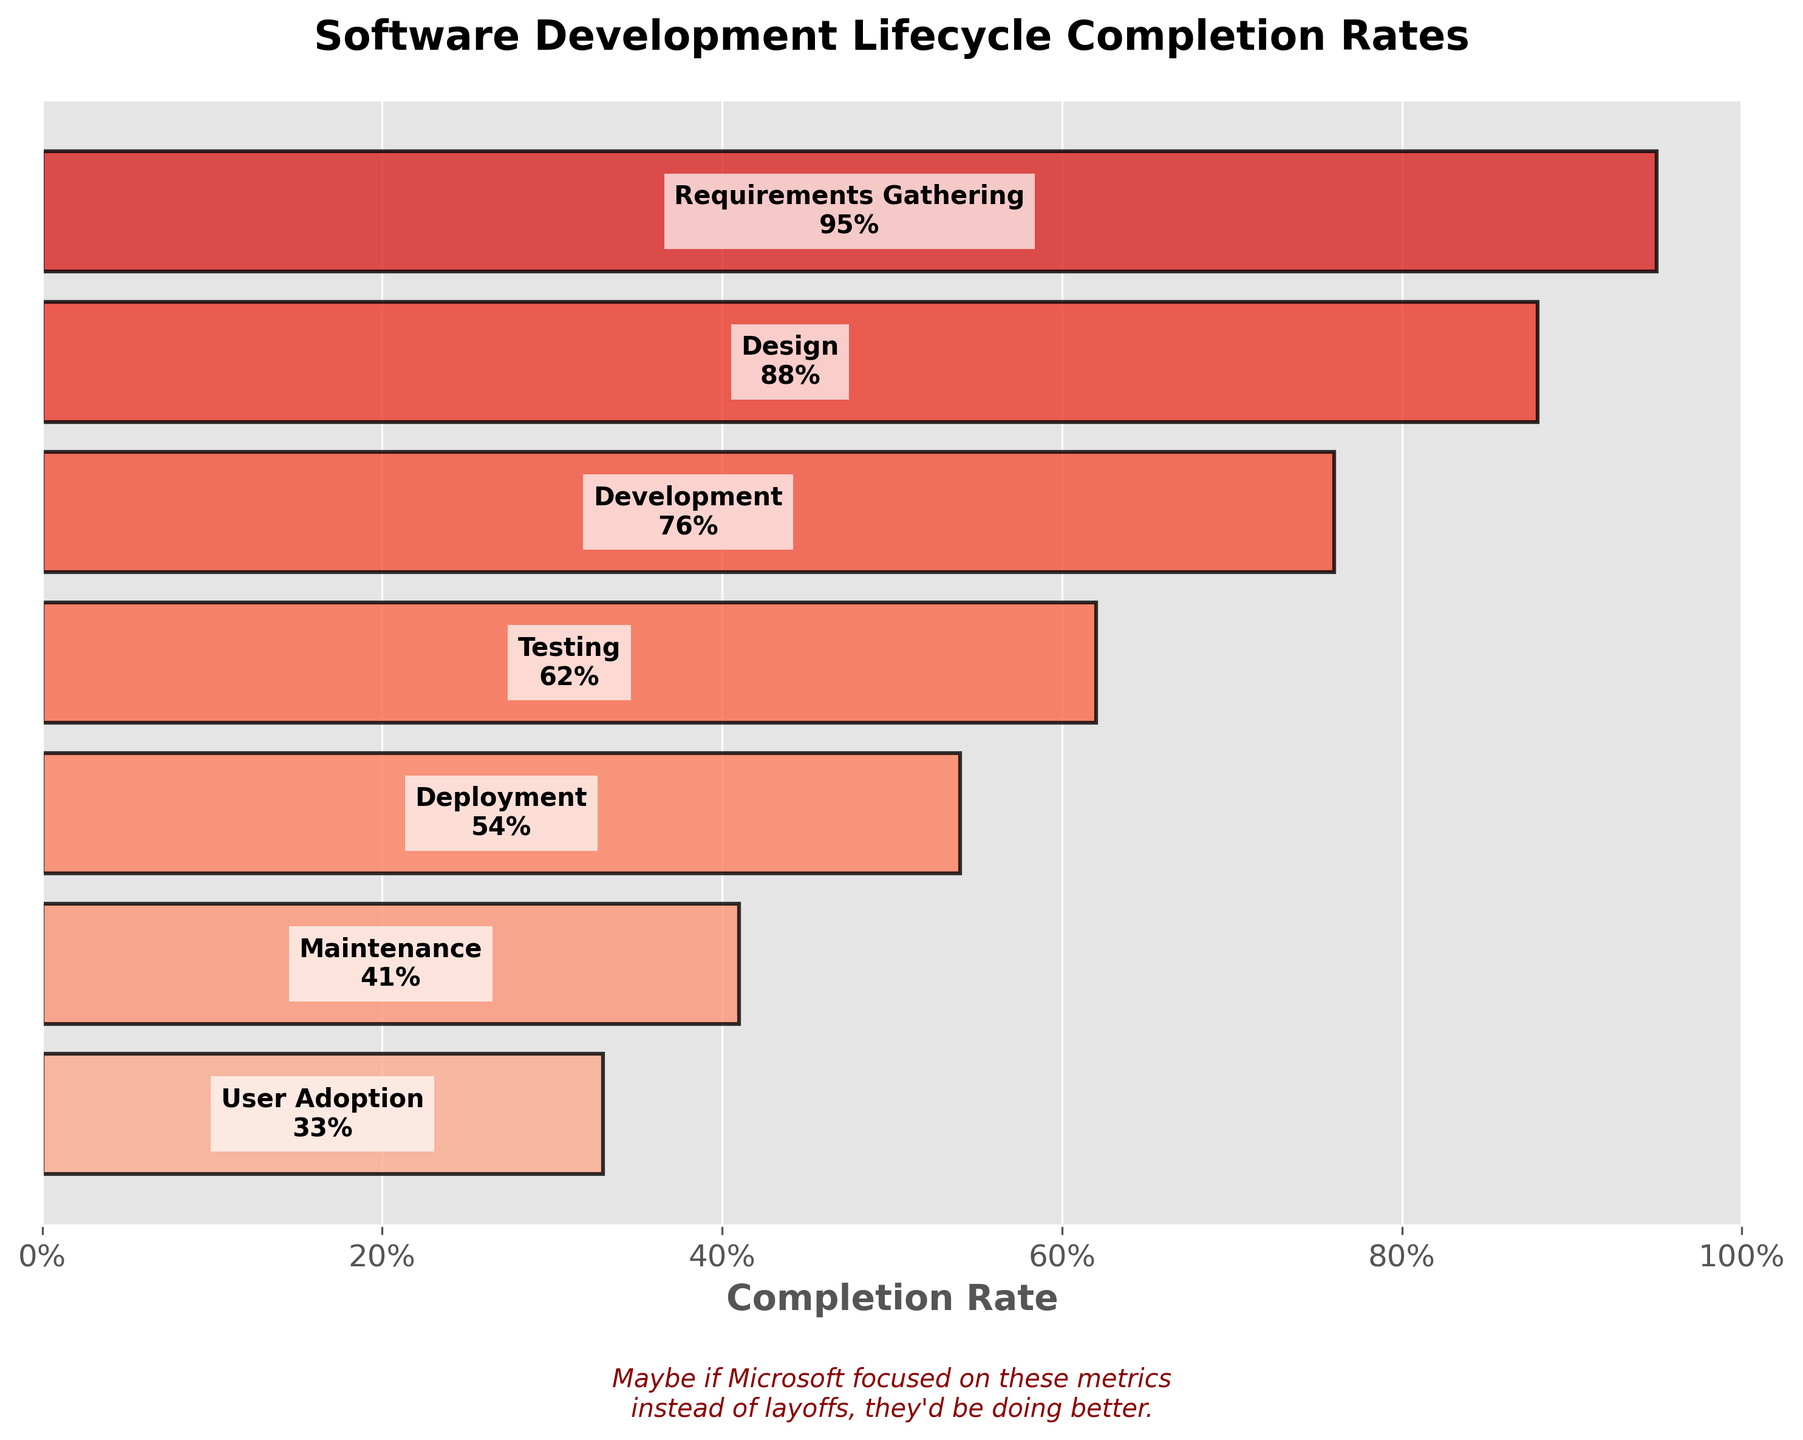What is the title of the funnel chart? The title is usually placed at the top of the chart. Looking at the top, we see the title "Software Development Lifecycle Completion Rates".
Answer: Software Development Lifecycle Completion Rates Which stage has the highest completion rate? The highest bar on the funnel chart represents the highest completion rate. The first stage, "Requirements Gathering," has the bar extended to 95%.
Answer: Requirements Gathering What is the completion rate for the "Testing" stage? By looking for the "Testing" stage on the chart and reading the percentage next to it, we see that it has a completion rate of 62%.
Answer: 62% How many stages are displayed in the funnel chart? Counting all the stages listed in the chart from top to bottom, there are 7 stages.
Answer: 7 Which stage shows the largest drop in completion rate compared to the previous stage? To answer this, calculate the difference between each consecutive pair of stages and compare. The biggest drop is between "Requirements Gathering" (95%) and "Design" (88%), which is a difference of 7%. No other drop is larger.
Answer: Requirements Gathering to Design What is the average completion rate across all stages? Add all the completion rates (95 + 88 + 76 + 62 + 54 + 41 + 33) and divide by the number of stages (7). The sum is 449, and 449/7 is approximately 64.14%.
Answer: 64.14% How does the completion rate of the "Development" stage compare to the "Maintenance" stage? Looking at the chart, the "Development" stage has a completion rate of 76%, and the "Maintenance" stage has a rate of 41%. Comparing the two, 76% is greater than 41%.
Answer: Development is greater than Maintenance What is the combined completion rate for the "Deployment" and "Design" stages? Add the rates for "Deployment" (54%) and "Design" (88%). The combined rate is 54 + 88 = 142.
Answer: 142 Which two stages have the smallest difference in their completion rates? Calculate the differences between each pair of consecutive stages and find the smallest one. Between "Testing" (62%) and "Deployment" (54%), the difference is 62 - 54 = 8%, which is the smallest difference.
Answer: Testing and Deployment Does any stage have a completion rate below 40%? Look through the chart for any completion rates below 40%. The "User Adoption" stage has a rate of 33%, which is below 40%.
Answer: Yes, User Adoption 